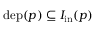Convert formula to latex. <formula><loc_0><loc_0><loc_500><loc_500>d e p ( p ) \subseteq I _ { i n } ( p )</formula> 